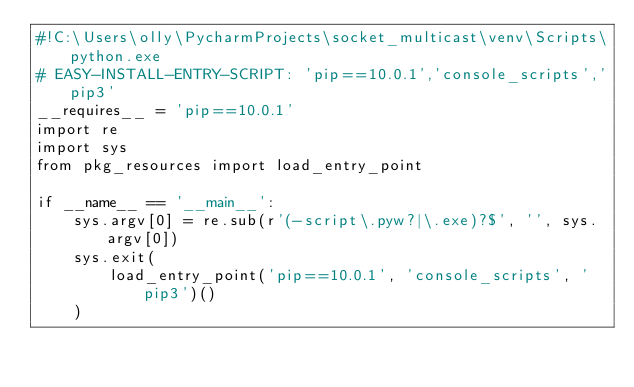<code> <loc_0><loc_0><loc_500><loc_500><_Python_>#!C:\Users\olly\PycharmProjects\socket_multicast\venv\Scripts\python.exe
# EASY-INSTALL-ENTRY-SCRIPT: 'pip==10.0.1','console_scripts','pip3'
__requires__ = 'pip==10.0.1'
import re
import sys
from pkg_resources import load_entry_point

if __name__ == '__main__':
    sys.argv[0] = re.sub(r'(-script\.pyw?|\.exe)?$', '', sys.argv[0])
    sys.exit(
        load_entry_point('pip==10.0.1', 'console_scripts', 'pip3')()
    )
</code> 